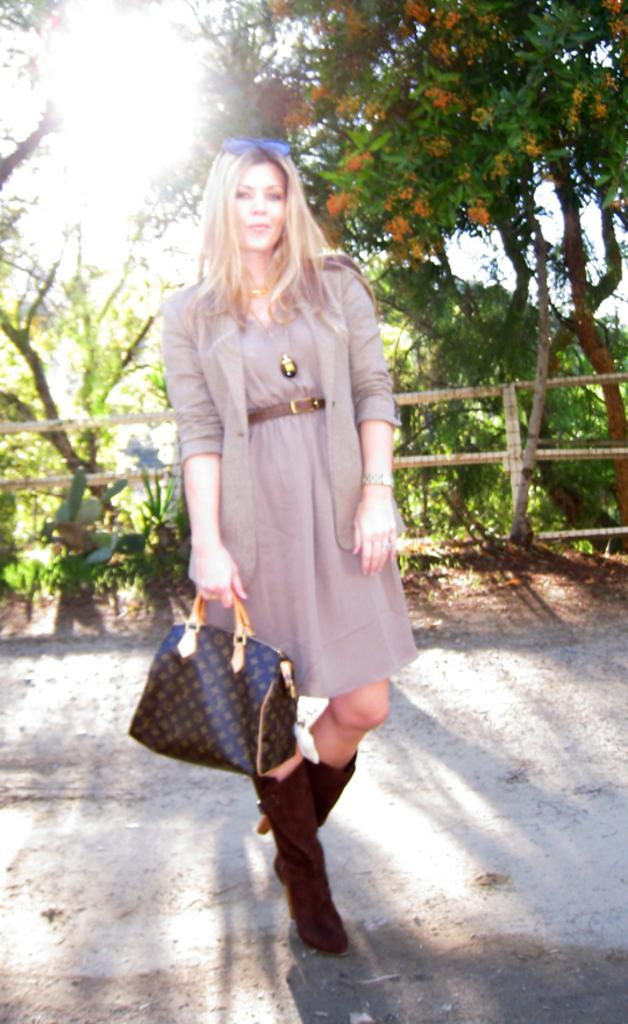What type of vegetation can be seen in the image? There are trees in the image. Who is present in the image? There is a woman in the image. What is the woman holding in the image? The woman is holding a handbag. What type of produce is the woman picking from the trees in the image? There are no trees with produce in the image, and the woman is not picking anything from the trees. What arithmetic problem is the woman solving in the image? There is no arithmetic problem present in the image. 